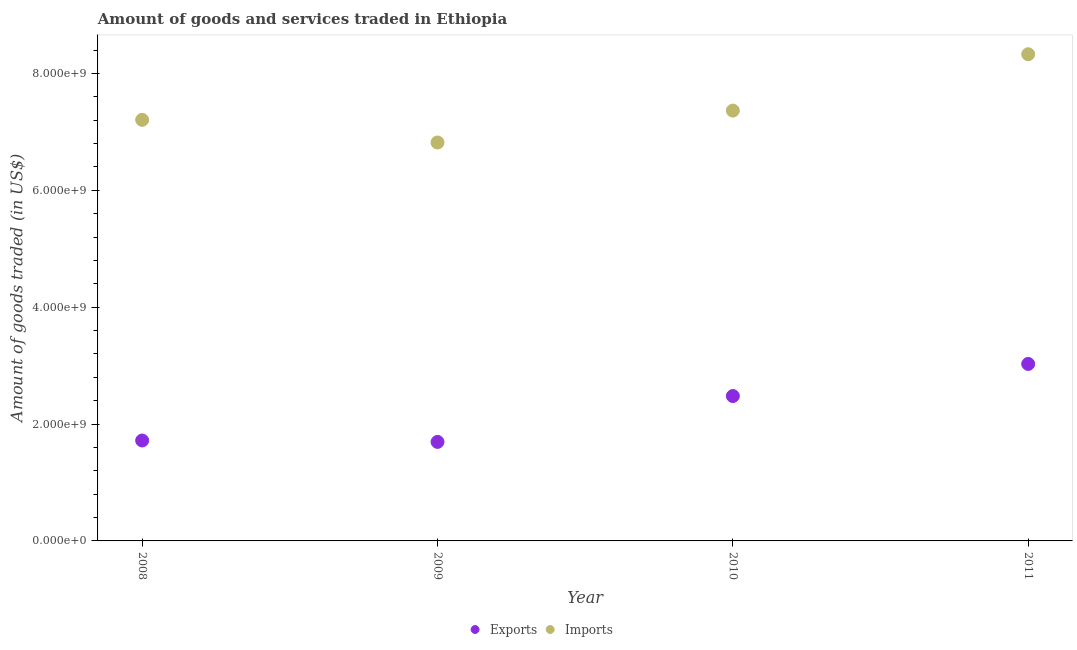What is the amount of goods exported in 2008?
Offer a terse response. 1.72e+09. Across all years, what is the maximum amount of goods imported?
Offer a terse response. 8.33e+09. Across all years, what is the minimum amount of goods exported?
Make the answer very short. 1.69e+09. In which year was the amount of goods exported maximum?
Provide a short and direct response. 2011. What is the total amount of goods exported in the graph?
Your response must be concise. 8.92e+09. What is the difference between the amount of goods exported in 2008 and that in 2011?
Your answer should be very brief. -1.31e+09. What is the difference between the amount of goods exported in 2010 and the amount of goods imported in 2009?
Give a very brief answer. -4.34e+09. What is the average amount of goods imported per year?
Provide a short and direct response. 7.43e+09. In the year 2008, what is the difference between the amount of goods exported and amount of goods imported?
Provide a short and direct response. -5.49e+09. What is the ratio of the amount of goods exported in 2009 to that in 2010?
Give a very brief answer. 0.68. Is the amount of goods imported in 2009 less than that in 2011?
Make the answer very short. Yes. Is the difference between the amount of goods exported in 2008 and 2011 greater than the difference between the amount of goods imported in 2008 and 2011?
Your answer should be very brief. No. What is the difference between the highest and the second highest amount of goods exported?
Make the answer very short. 5.50e+08. What is the difference between the highest and the lowest amount of goods imported?
Your answer should be compact. 1.51e+09. In how many years, is the amount of goods exported greater than the average amount of goods exported taken over all years?
Ensure brevity in your answer.  2. Does the amount of goods exported monotonically increase over the years?
Make the answer very short. No. Is the amount of goods imported strictly greater than the amount of goods exported over the years?
Offer a terse response. Yes. How many years are there in the graph?
Keep it short and to the point. 4. What is the difference between two consecutive major ticks on the Y-axis?
Offer a very short reply. 2.00e+09. Where does the legend appear in the graph?
Offer a very short reply. Bottom center. How many legend labels are there?
Keep it short and to the point. 2. How are the legend labels stacked?
Keep it short and to the point. Horizontal. What is the title of the graph?
Offer a very short reply. Amount of goods and services traded in Ethiopia. What is the label or title of the Y-axis?
Give a very brief answer. Amount of goods traded (in US$). What is the Amount of goods traded (in US$) of Exports in 2008?
Give a very brief answer. 1.72e+09. What is the Amount of goods traded (in US$) in Imports in 2008?
Offer a terse response. 7.21e+09. What is the Amount of goods traded (in US$) in Exports in 2009?
Make the answer very short. 1.69e+09. What is the Amount of goods traded (in US$) in Imports in 2009?
Provide a short and direct response. 6.82e+09. What is the Amount of goods traded (in US$) in Exports in 2010?
Provide a short and direct response. 2.48e+09. What is the Amount of goods traded (in US$) in Imports in 2010?
Offer a very short reply. 7.36e+09. What is the Amount of goods traded (in US$) in Exports in 2011?
Your answer should be compact. 3.03e+09. What is the Amount of goods traded (in US$) in Imports in 2011?
Give a very brief answer. 8.33e+09. Across all years, what is the maximum Amount of goods traded (in US$) in Exports?
Provide a succinct answer. 3.03e+09. Across all years, what is the maximum Amount of goods traded (in US$) in Imports?
Give a very brief answer. 8.33e+09. Across all years, what is the minimum Amount of goods traded (in US$) of Exports?
Offer a terse response. 1.69e+09. Across all years, what is the minimum Amount of goods traded (in US$) in Imports?
Give a very brief answer. 6.82e+09. What is the total Amount of goods traded (in US$) of Exports in the graph?
Give a very brief answer. 8.92e+09. What is the total Amount of goods traded (in US$) in Imports in the graph?
Offer a terse response. 2.97e+1. What is the difference between the Amount of goods traded (in US$) of Exports in 2008 and that in 2009?
Give a very brief answer. 2.39e+07. What is the difference between the Amount of goods traded (in US$) in Imports in 2008 and that in 2009?
Provide a succinct answer. 3.87e+08. What is the difference between the Amount of goods traded (in US$) in Exports in 2008 and that in 2010?
Keep it short and to the point. -7.61e+08. What is the difference between the Amount of goods traded (in US$) in Imports in 2008 and that in 2010?
Make the answer very short. -1.58e+08. What is the difference between the Amount of goods traded (in US$) of Exports in 2008 and that in 2011?
Your answer should be compact. -1.31e+09. What is the difference between the Amount of goods traded (in US$) in Imports in 2008 and that in 2011?
Ensure brevity in your answer.  -1.12e+09. What is the difference between the Amount of goods traded (in US$) of Exports in 2009 and that in 2010?
Your answer should be very brief. -7.85e+08. What is the difference between the Amount of goods traded (in US$) of Imports in 2009 and that in 2010?
Your answer should be very brief. -5.45e+08. What is the difference between the Amount of goods traded (in US$) of Exports in 2009 and that in 2011?
Your response must be concise. -1.33e+09. What is the difference between the Amount of goods traded (in US$) of Imports in 2009 and that in 2011?
Give a very brief answer. -1.51e+09. What is the difference between the Amount of goods traded (in US$) of Exports in 2010 and that in 2011?
Keep it short and to the point. -5.50e+08. What is the difference between the Amount of goods traded (in US$) in Imports in 2010 and that in 2011?
Provide a short and direct response. -9.64e+08. What is the difference between the Amount of goods traded (in US$) in Exports in 2008 and the Amount of goods traded (in US$) in Imports in 2009?
Your answer should be very brief. -5.10e+09. What is the difference between the Amount of goods traded (in US$) in Exports in 2008 and the Amount of goods traded (in US$) in Imports in 2010?
Your answer should be very brief. -5.65e+09. What is the difference between the Amount of goods traded (in US$) in Exports in 2008 and the Amount of goods traded (in US$) in Imports in 2011?
Give a very brief answer. -6.61e+09. What is the difference between the Amount of goods traded (in US$) of Exports in 2009 and the Amount of goods traded (in US$) of Imports in 2010?
Provide a short and direct response. -5.67e+09. What is the difference between the Amount of goods traded (in US$) in Exports in 2009 and the Amount of goods traded (in US$) in Imports in 2011?
Make the answer very short. -6.63e+09. What is the difference between the Amount of goods traded (in US$) in Exports in 2010 and the Amount of goods traded (in US$) in Imports in 2011?
Give a very brief answer. -5.85e+09. What is the average Amount of goods traded (in US$) of Exports per year?
Offer a terse response. 2.23e+09. What is the average Amount of goods traded (in US$) of Imports per year?
Make the answer very short. 7.43e+09. In the year 2008, what is the difference between the Amount of goods traded (in US$) of Exports and Amount of goods traded (in US$) of Imports?
Your response must be concise. -5.49e+09. In the year 2009, what is the difference between the Amount of goods traded (in US$) of Exports and Amount of goods traded (in US$) of Imports?
Offer a terse response. -5.12e+09. In the year 2010, what is the difference between the Amount of goods traded (in US$) of Exports and Amount of goods traded (in US$) of Imports?
Ensure brevity in your answer.  -4.89e+09. In the year 2011, what is the difference between the Amount of goods traded (in US$) of Exports and Amount of goods traded (in US$) of Imports?
Your answer should be very brief. -5.30e+09. What is the ratio of the Amount of goods traded (in US$) of Exports in 2008 to that in 2009?
Offer a very short reply. 1.01. What is the ratio of the Amount of goods traded (in US$) of Imports in 2008 to that in 2009?
Offer a terse response. 1.06. What is the ratio of the Amount of goods traded (in US$) in Exports in 2008 to that in 2010?
Provide a short and direct response. 0.69. What is the ratio of the Amount of goods traded (in US$) in Imports in 2008 to that in 2010?
Offer a terse response. 0.98. What is the ratio of the Amount of goods traded (in US$) of Exports in 2008 to that in 2011?
Ensure brevity in your answer.  0.57. What is the ratio of the Amount of goods traded (in US$) in Imports in 2008 to that in 2011?
Make the answer very short. 0.87. What is the ratio of the Amount of goods traded (in US$) in Exports in 2009 to that in 2010?
Make the answer very short. 0.68. What is the ratio of the Amount of goods traded (in US$) of Imports in 2009 to that in 2010?
Your answer should be very brief. 0.93. What is the ratio of the Amount of goods traded (in US$) of Exports in 2009 to that in 2011?
Make the answer very short. 0.56. What is the ratio of the Amount of goods traded (in US$) of Imports in 2009 to that in 2011?
Your answer should be very brief. 0.82. What is the ratio of the Amount of goods traded (in US$) of Exports in 2010 to that in 2011?
Keep it short and to the point. 0.82. What is the ratio of the Amount of goods traded (in US$) in Imports in 2010 to that in 2011?
Make the answer very short. 0.88. What is the difference between the highest and the second highest Amount of goods traded (in US$) of Exports?
Give a very brief answer. 5.50e+08. What is the difference between the highest and the second highest Amount of goods traded (in US$) in Imports?
Provide a succinct answer. 9.64e+08. What is the difference between the highest and the lowest Amount of goods traded (in US$) of Exports?
Give a very brief answer. 1.33e+09. What is the difference between the highest and the lowest Amount of goods traded (in US$) of Imports?
Provide a short and direct response. 1.51e+09. 